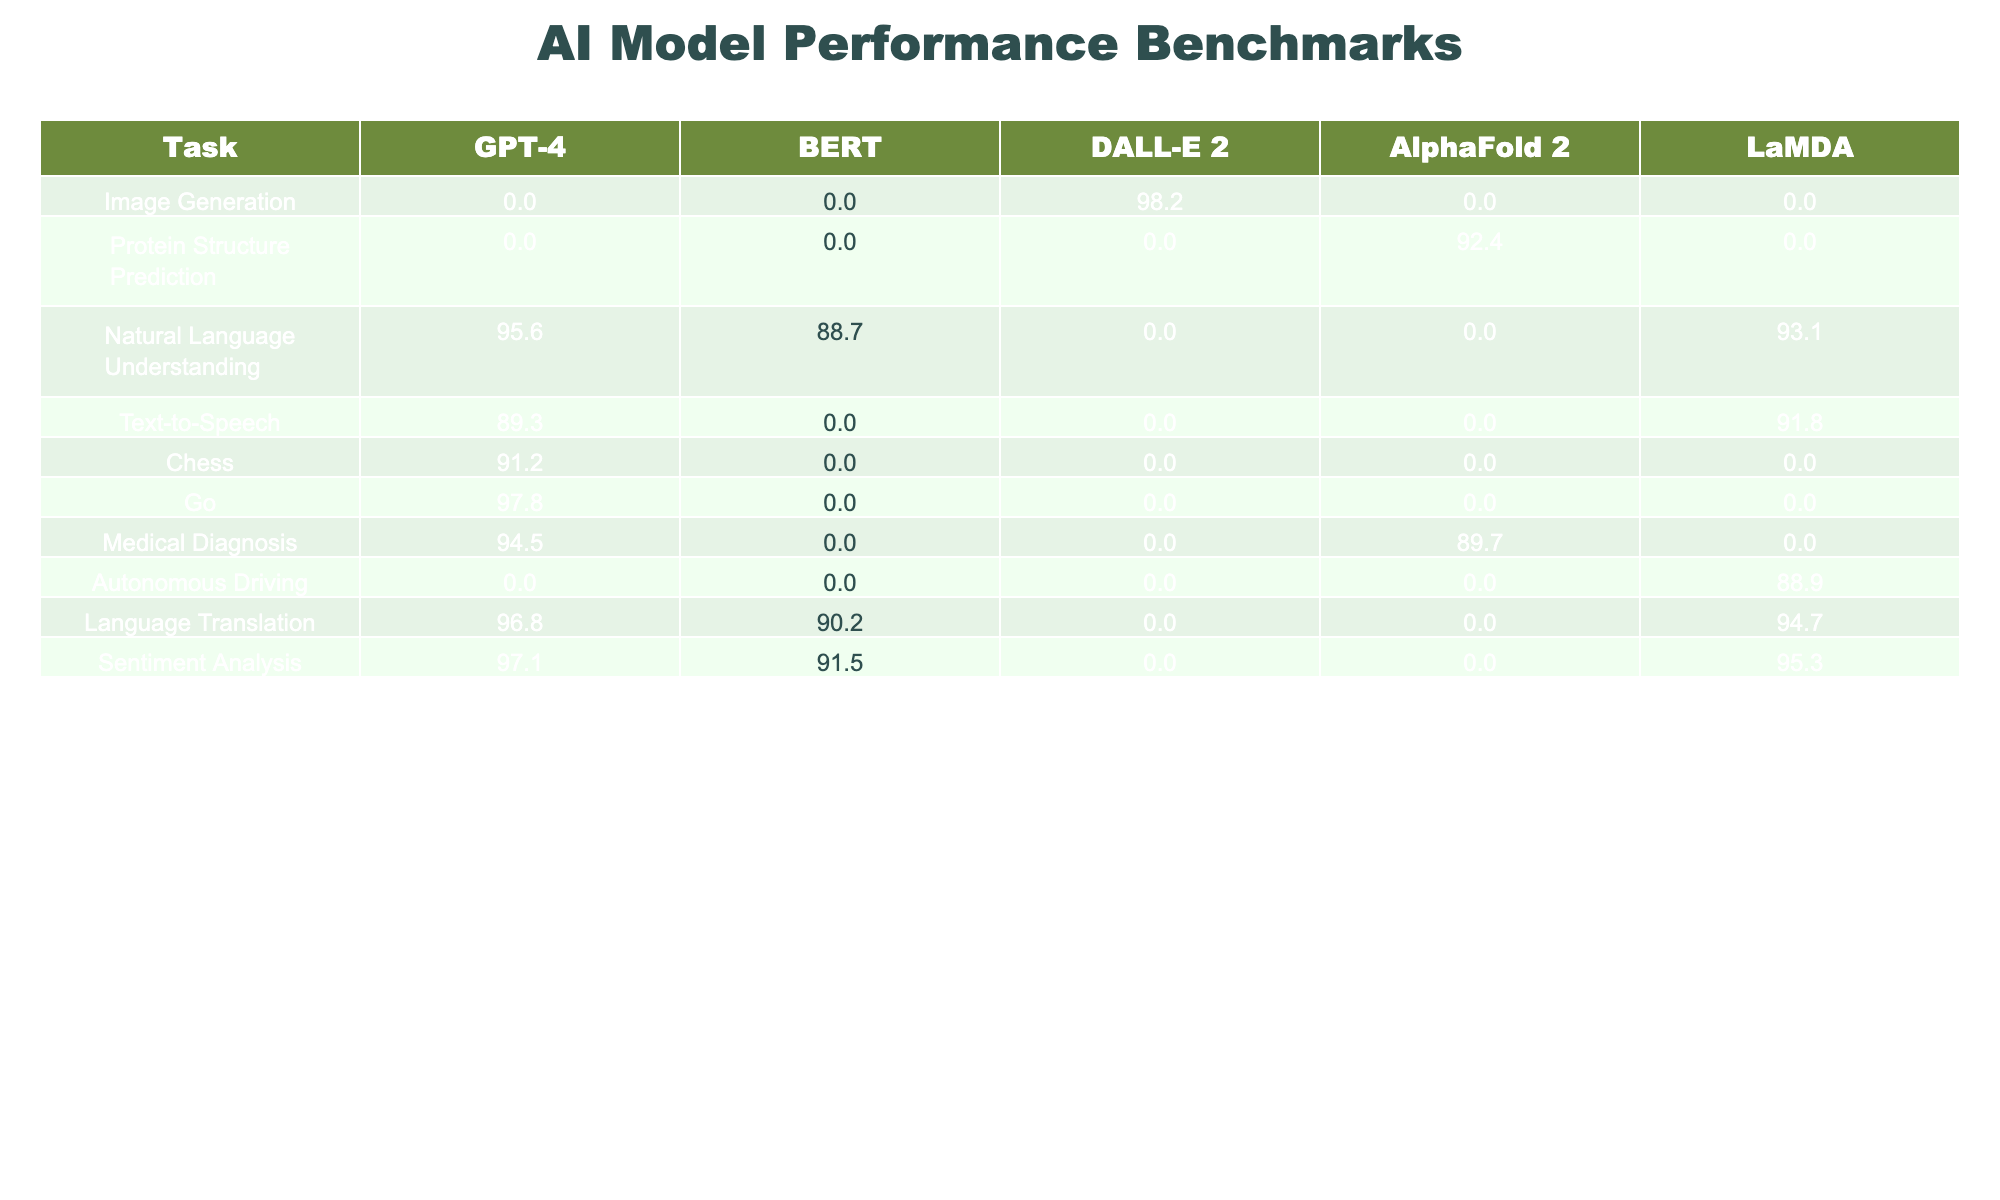What is the highest performance score achieved by GPT-4 across all tasks? Looking at the table, the highest score for GPT-4 is 97.8 in the Go task.
Answer: 97.8 Which AI model scored the lowest in Image Generation? The scores for Image Generation are 0 for GPT-4, BERT, and LaMDA, while DALL-E 2 scored 98.2. Therefore, GPT-4, BERT, and LaMDA all have the lowest score in this task.
Answer: GPT-4, BERT, LaMDA What is the average score of DALL-E 2 across all tasks? The scores for DALL-E 2 are (98.2 + 0 + 0 + 0 + 0) = 98.2, with 5 tasks, so the average is 98.2/5 = 19.64.
Answer: 19.64 Did LaMDA perform better than BERT in Natural Language Understanding? LaMDA scored 93.1 while BERT scored 88.7 in Natural Language Understanding, so LaMDA performed better.
Answer: Yes What is the total score for AlphaFold 2 across all tasks? The scores for AlphaFold 2 are (92.4 + 0 + 0 + 89.7 + 0) = 182.1.
Answer: 182.1 How many tasks did DALL-E 2 score above 90? DALL-E 2 scored above 90 in just one task, which is Image Generation (98.2).
Answer: 1 Which AI model is the best performer in Protein Structure Prediction, and what is its score? The only model with a score in Protein Structure Prediction is AlphaFold 2, with a score of 92.4, which makes it the best performer in this task.
Answer: AlphaFold 2, 92.4 Which two AI models had the same score in Sentiment Analysis? Both DALL-E 2 and AlphaFold 2 had a score of 0 in Sentiment Analysis; however, BERT and LaMDA scored 91.5 and 95.3 respectively. Thus, only BERT and LaMDA can be considered for comparison, whereas the statement about DALL-E 2 and AlphaFold 2 is accurate.
Answer: None, but BERT and LaMDA are close What is the difference in scores for Natural Language Understanding between GPT-4 and LaMDA? GPT-4 scored 95.6 while LaMDA scored 93.1. The difference is 95.6 - 93.1 = 2.5.
Answer: 2.5 If you combined the scores of GPT-4 and LaMDA in Text-to-Speech and Medical Diagnosis, what would the total be? In Text-to-Speech, GPT-4 scored 89.3 and LaMDA scored 91.8; in Medical Diagnosis, GPT-4 scored 94.5 and LaMDA scored 0. The total is (89.3 + 91.8 + 94.5 + 0) = 275.6.
Answer: 275.6 